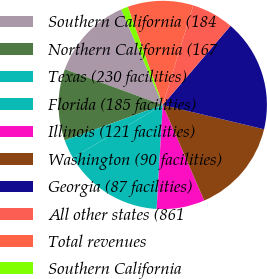Convert chart to OTSL. <chart><loc_0><loc_0><loc_500><loc_500><pie_chart><fcel>Southern California (184<fcel>Northern California (167<fcel>Texas (230 facilities)<fcel>Florida (185 facilities)<fcel>Illinois (121 facilities)<fcel>Washington (90 facilities)<fcel>Georgia (87 facilities)<fcel>All other states (861<fcel>Total revenues<fcel>Southern California<nl><fcel>12.91%<fcel>11.09%<fcel>2.9%<fcel>15.65%<fcel>7.45%<fcel>14.74%<fcel>17.47%<fcel>6.54%<fcel>10.18%<fcel>1.08%<nl></chart> 